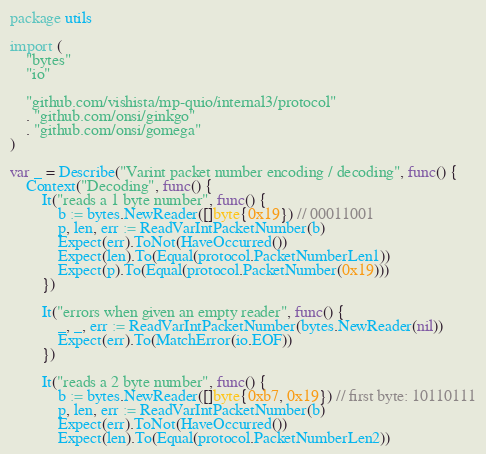<code> <loc_0><loc_0><loc_500><loc_500><_Go_>package utils

import (
	"bytes"
	"io"

	"github.com/vishista/mp-quio/internal3/protocol"
	. "github.com/onsi/ginkgo"
	. "github.com/onsi/gomega"
)

var _ = Describe("Varint packet number encoding / decoding", func() {
	Context("Decoding", func() {
		It("reads a 1 byte number", func() {
			b := bytes.NewReader([]byte{0x19}) // 00011001
			p, len, err := ReadVarIntPacketNumber(b)
			Expect(err).ToNot(HaveOccurred())
			Expect(len).To(Equal(protocol.PacketNumberLen1))
			Expect(p).To(Equal(protocol.PacketNumber(0x19)))
		})

		It("errors when given an empty reader", func() {
			_, _, err := ReadVarIntPacketNumber(bytes.NewReader(nil))
			Expect(err).To(MatchError(io.EOF))
		})

		It("reads a 2 byte number", func() {
			b := bytes.NewReader([]byte{0xb7, 0x19}) // first byte: 10110111
			p, len, err := ReadVarIntPacketNumber(b)
			Expect(err).ToNot(HaveOccurred())
			Expect(len).To(Equal(protocol.PacketNumberLen2))</code> 